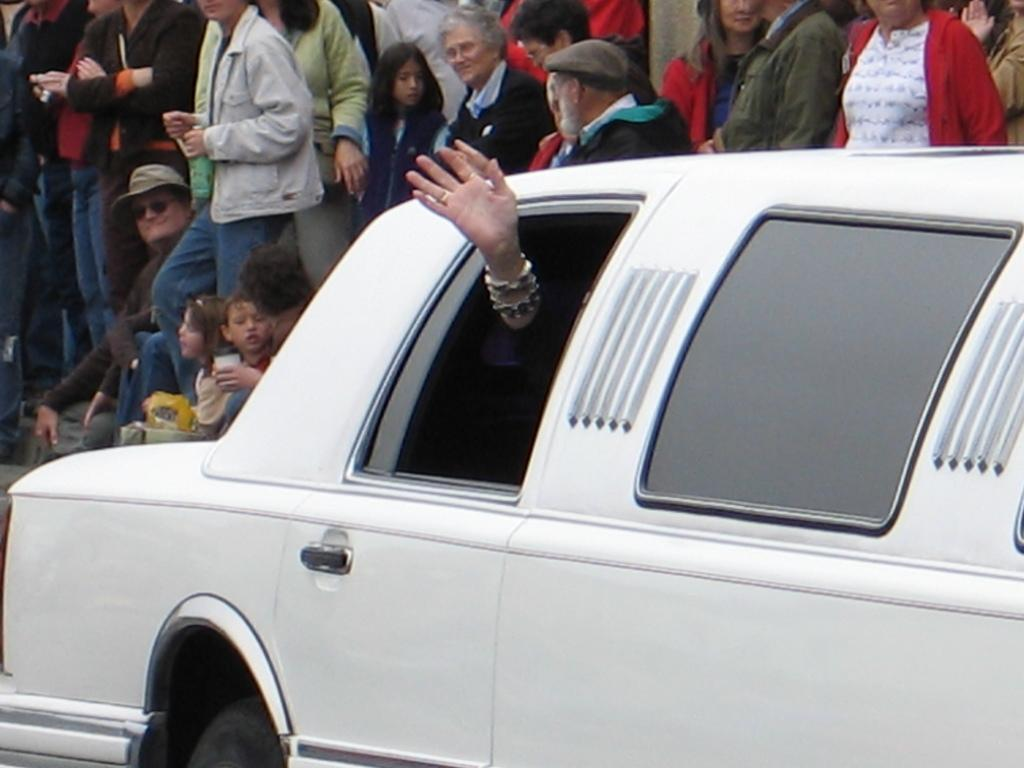What is the main subject of the image? There is a car in the image. What is the person in the car doing? A person's hand is waving from the car. How many people are visible in the image? There are many people standing behind the car, and a few people are sitting behind the car. What type of silk is being used to cover the desk in the image? There is no desk or silk present in the image; it features a car with people standing and sitting around it. 